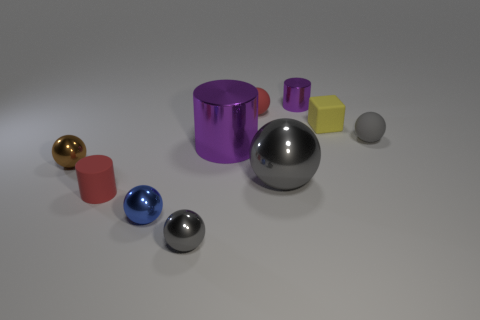Subtract all gray balls. How many were subtracted if there are1gray balls left? 2 Subtract all purple blocks. How many gray spheres are left? 3 Subtract all gray matte balls. How many balls are left? 5 Subtract all blue balls. How many balls are left? 5 Subtract all green cylinders. Subtract all brown spheres. How many cylinders are left? 3 Subtract all cylinders. How many objects are left? 7 Subtract 1 red balls. How many objects are left? 9 Subtract all small red matte things. Subtract all cylinders. How many objects are left? 5 Add 3 tiny gray rubber objects. How many tiny gray rubber objects are left? 4 Add 8 small matte balls. How many small matte balls exist? 10 